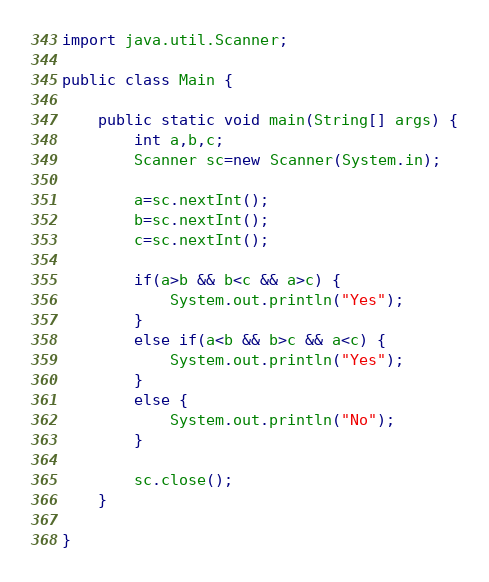Convert code to text. <code><loc_0><loc_0><loc_500><loc_500><_Java_>import java.util.Scanner;

public class Main {

	public static void main(String[] args) {
		int a,b,c;
		Scanner sc=new Scanner(System.in);

		a=sc.nextInt();
		b=sc.nextInt();
		c=sc.nextInt();

		if(a>b && b<c && a>c) {
			System.out.println("Yes");
		}
		else if(a<b && b>c && a<c) {
			System.out.println("Yes");
		}
		else {
			System.out.println("No");
		}

		sc.close();
	}

}</code> 